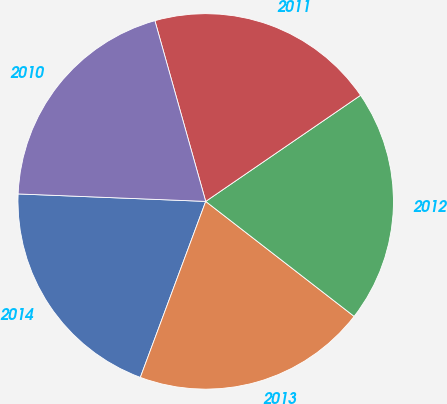Convert chart. <chart><loc_0><loc_0><loc_500><loc_500><pie_chart><fcel>2014<fcel>2013<fcel>2012<fcel>2011<fcel>2010<nl><fcel>19.97%<fcel>20.17%<fcel>20.05%<fcel>19.8%<fcel>20.0%<nl></chart> 